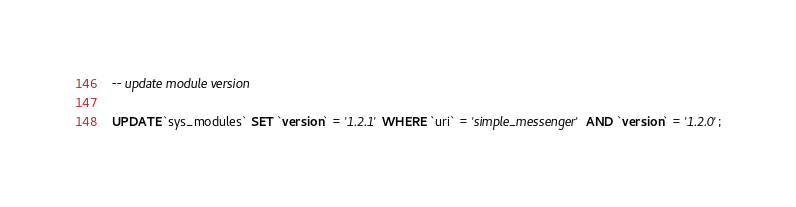Convert code to text. <code><loc_0><loc_0><loc_500><loc_500><_SQL_>

-- update module version

UPDATE `sys_modules` SET `version` = '1.2.1' WHERE `uri` = 'simple_messenger' AND `version` = '1.2.0';

</code> 